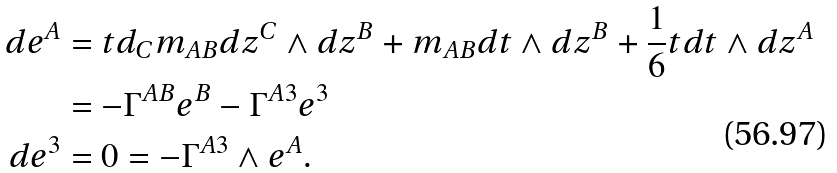Convert formula to latex. <formula><loc_0><loc_0><loc_500><loc_500>d e ^ { A } & = t d _ { C } m _ { A B } d z ^ { C } \wedge d z ^ { B } + m _ { A B } d t \wedge d z ^ { B } + \frac { 1 } { 6 } t d t \wedge d z ^ { A } \\ & = - \Gamma ^ { A B } e ^ { B } - \Gamma ^ { A 3 } e ^ { 3 } \\ d e ^ { 3 } & = 0 = - \Gamma ^ { A 3 } \wedge e ^ { A } .</formula> 